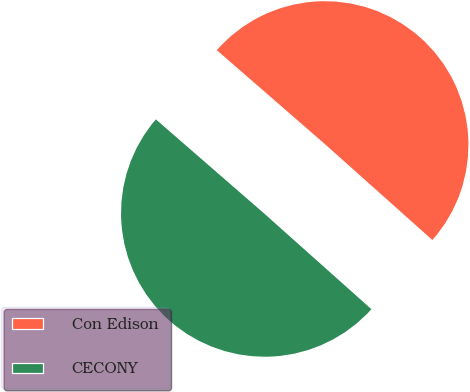Convert chart to OTSL. <chart><loc_0><loc_0><loc_500><loc_500><pie_chart><fcel>Con Edison<fcel>CECONY<nl><fcel>50.21%<fcel>49.79%<nl></chart> 